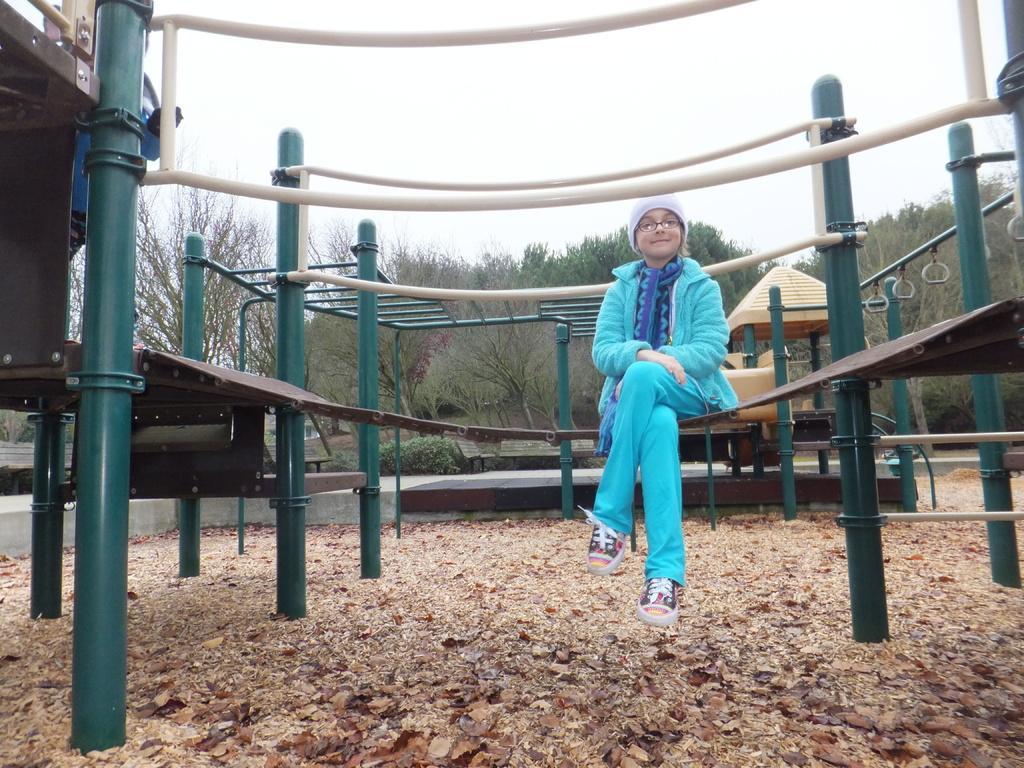Could you give a brief overview of what you see in this image? In this image I can see a girl is sitting, she is wearing trouser, sweater, spectacles. In the background there is the children play equipment and there are trees, at the top there is the sky. 